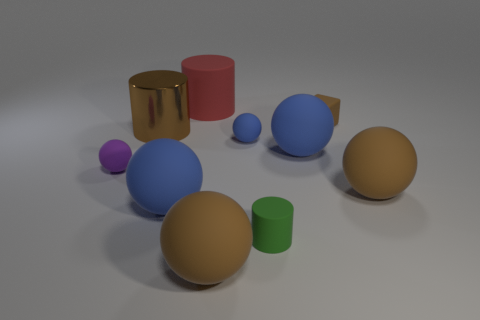What number of objects are rubber things right of the brown metal cylinder or rubber blocks?
Give a very brief answer. 8. Is there a blue thing of the same size as the block?
Provide a succinct answer. Yes. Is the number of tiny yellow matte balls less than the number of red matte things?
Offer a very short reply. Yes. How many cylinders are either tiny brown things or shiny things?
Offer a terse response. 1. What number of metallic cylinders are the same color as the tiny rubber block?
Offer a very short reply. 1. What size is the thing that is behind the metallic object and on the right side of the big rubber cylinder?
Give a very brief answer. Small. Are there fewer tiny blue matte balls in front of the small green thing than cyan matte cylinders?
Your answer should be compact. No. Does the large red cylinder have the same material as the tiny green object?
Your response must be concise. Yes. What number of things are large purple metal objects or big brown rubber objects?
Make the answer very short. 2. What number of tiny brown things are made of the same material as the brown cylinder?
Make the answer very short. 0. 